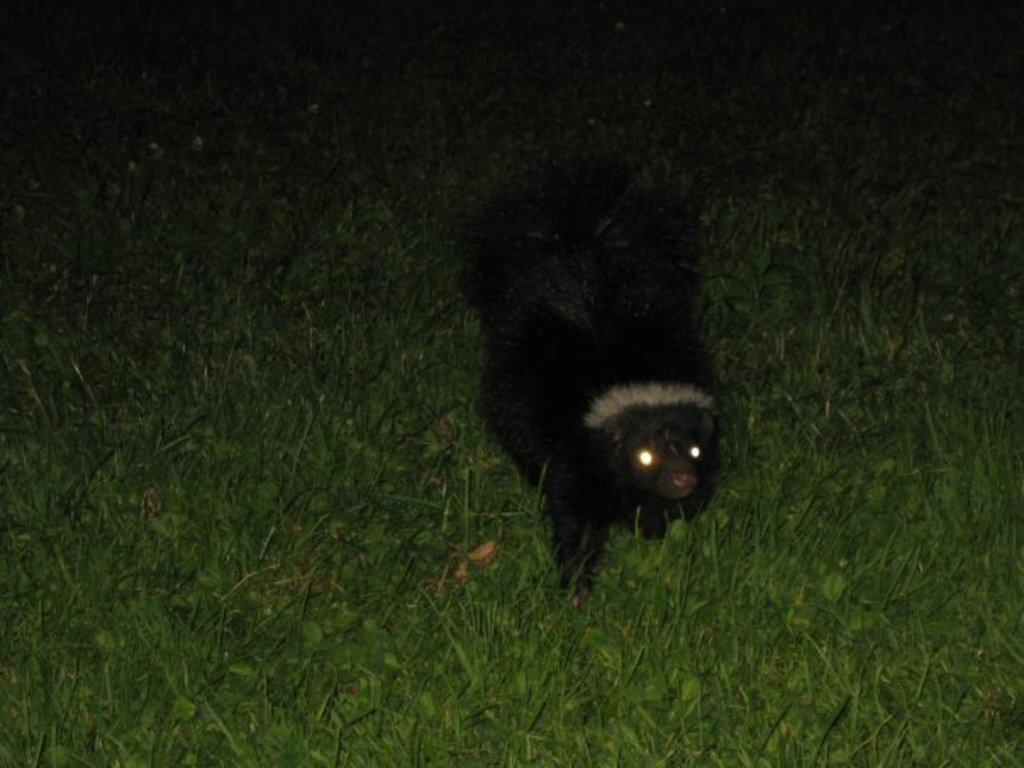What is the main subject in the center of the image? There is an animal in the center of the image. What type of surface is the animal on? The animal is on the grass. What type of sign can be seen in the image? There is no sign present in the image; it features an animal on the grass. What type of vessel is the animal using to play in the image? There is no vessel present in the image, and the animal is not shown playing. 